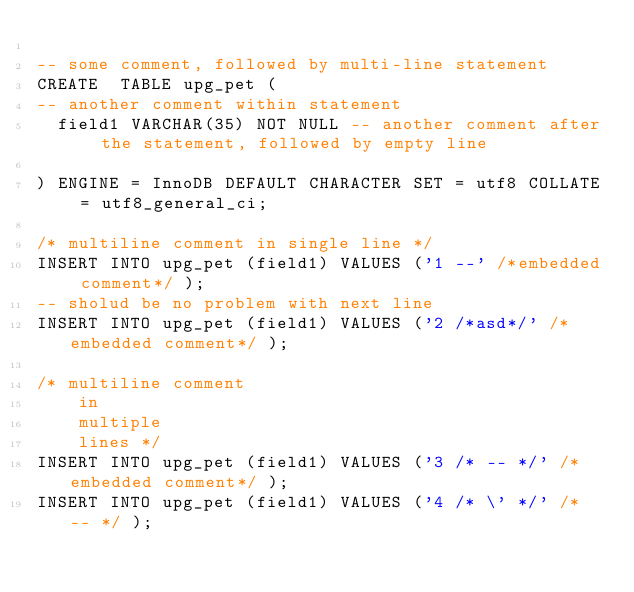Convert code to text. <code><loc_0><loc_0><loc_500><loc_500><_SQL_>
-- some comment, followed by multi-line statement
CREATE  TABLE upg_pet (
-- another comment within statement
  field1 VARCHAR(35) NOT NULL -- another comment after the statement, followed by empty line

) ENGINE = InnoDB DEFAULT CHARACTER SET = utf8 COLLATE = utf8_general_ci;

/* multiline comment in single line */
INSERT INTO upg_pet (field1) VALUES ('1 --' /*embedded comment*/ );
-- sholud be no problem with next line
INSERT INTO upg_pet (field1) VALUES ('2 /*asd*/' /*embedded comment*/ );

/* multiline comment 
    in 
    multiple
    lines */
INSERT INTO upg_pet (field1) VALUES ('3 /* -- */' /*embedded comment*/ );
INSERT INTO upg_pet (field1) VALUES ('4 /* \' */' /* -- */ );

</code> 